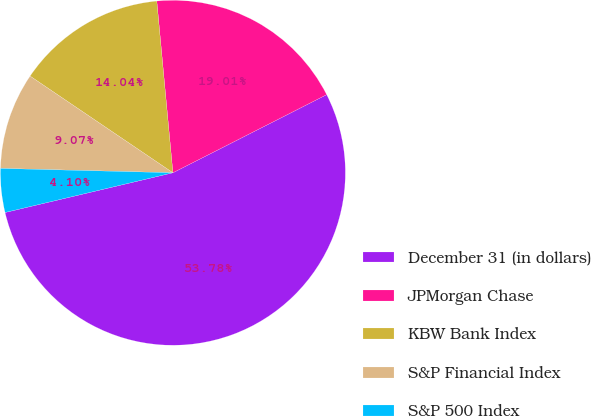Convert chart to OTSL. <chart><loc_0><loc_0><loc_500><loc_500><pie_chart><fcel>December 31 (in dollars)<fcel>JPMorgan Chase<fcel>KBW Bank Index<fcel>S&P Financial Index<fcel>S&P 500 Index<nl><fcel>53.78%<fcel>19.01%<fcel>14.04%<fcel>9.07%<fcel>4.1%<nl></chart> 